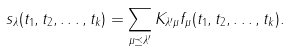<formula> <loc_0><loc_0><loc_500><loc_500>s _ { \lambda } ( t _ { 1 } , t _ { 2 } , \dots , t _ { k } ) = \sum _ { \mu \preceq \lambda ^ { \prime } } K _ { \lambda ^ { \prime } \mu } f _ { \mu } ( t _ { 1 } , t _ { 2 } , \dots , t _ { k } ) .</formula> 